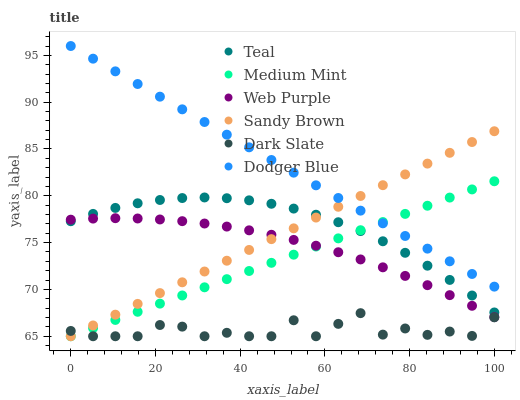Does Dark Slate have the minimum area under the curve?
Answer yes or no. Yes. Does Dodger Blue have the maximum area under the curve?
Answer yes or no. Yes. Does Web Purple have the minimum area under the curve?
Answer yes or no. No. Does Web Purple have the maximum area under the curve?
Answer yes or no. No. Is Dodger Blue the smoothest?
Answer yes or no. Yes. Is Dark Slate the roughest?
Answer yes or no. Yes. Is Web Purple the smoothest?
Answer yes or no. No. Is Web Purple the roughest?
Answer yes or no. No. Does Medium Mint have the lowest value?
Answer yes or no. Yes. Does Web Purple have the lowest value?
Answer yes or no. No. Does Dodger Blue have the highest value?
Answer yes or no. Yes. Does Web Purple have the highest value?
Answer yes or no. No. Is Dark Slate less than Teal?
Answer yes or no. Yes. Is Teal greater than Dark Slate?
Answer yes or no. Yes. Does Medium Mint intersect Web Purple?
Answer yes or no. Yes. Is Medium Mint less than Web Purple?
Answer yes or no. No. Is Medium Mint greater than Web Purple?
Answer yes or no. No. Does Dark Slate intersect Teal?
Answer yes or no. No. 